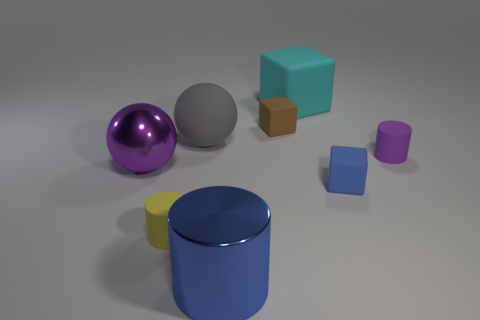Add 1 tiny rubber things. How many objects exist? 9 Subtract all spheres. How many objects are left? 6 Subtract 0 brown cylinders. How many objects are left? 8 Subtract all large gray cylinders. Subtract all large gray things. How many objects are left? 7 Add 5 large blue shiny things. How many large blue shiny things are left? 6 Add 2 tiny yellow things. How many tiny yellow things exist? 3 